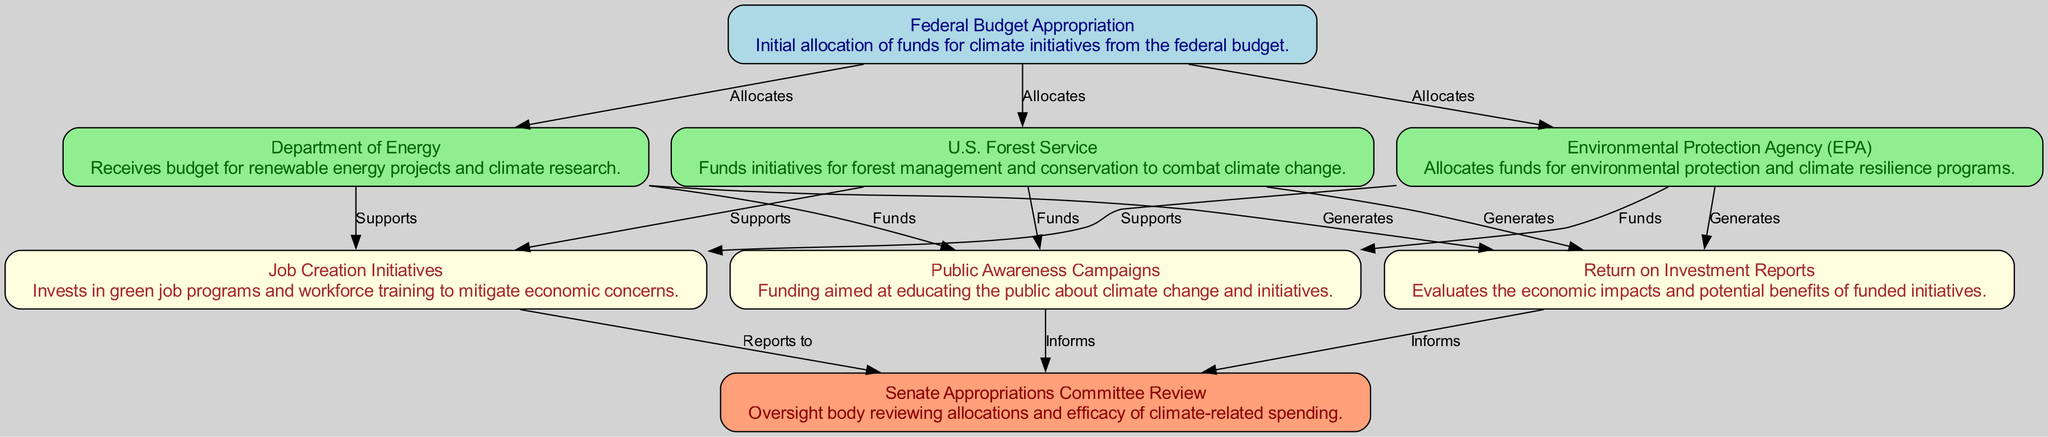What is the initial allocation of funds called? The first node in the diagram represents the starting point of the funding process, labeled "Federal Budget Appropriation." This is the term that designates the initial allocation of funds for climate initiatives.
Answer: Federal Budget Appropriation How many entities receive allocations from the federal budget? By examining the connections stemming from the "Federal Budget Appropriation" node, we see there are three entities listed: Department of Energy, Environmental Protection Agency, and U.S. Forest Service. This indicates a total of three recipients of budget allocations.
Answer: 3 Which entity is responsible for funding environmental protection programs? In the diagram, the node labeled "Environmental Protection Agency (EPA)" specifically states its function as allocating funds for environmental protection and climate resilience programs, making it the clear answer.
Answer: Environmental Protection Agency (EPA) What support does the Department of Energy provide? The flow from the "Department of Energy" shows an arrow leading to "Job Creation Initiatives," indicating that it supports investments in green job programs and workforce training, which directly mitigate economic concerns.
Answer: Job Creation Initiatives How does the diagram indicate economic impact assessments are performed? Following the paths from the funding entities, they all lead to the "Return on Investment Reports" node, which evaluates the economic impacts and benefits of the funding initiatives, demonstrating that economic assessments are a vital part of the process.
Answer: Return on Investment Reports Which node informs the Senate Appropriations Committee? The diagram illustrates that both "Return on Investment Reports" and "Public Awareness Campaigns" have connections pointing toward the "Senate Appropriations Committee Review," indicating that they inform this oversight body about climate-related spending efficacy.
Answer: Return on Investment Reports and Public Awareness Campaigns What is the primary purpose of the “Public Awareness Campaigns”? The node clearly states that the purpose of the "Public Awareness Campaigns" is to educate the public about climate change and initiatives, focusing on raising awareness and understanding.
Answer: Educating the public How many unique flows are generated from the "Federal Budget Appropriation" node? Analyzing the diagram, we can see that the "Federal Budget Appropriation" node generates three unique flows leading to the Department of Energy, EPA, and U.S. Forest Service, highlighting the distribution of funds.
Answer: 3 Which element directly supports funding for green jobs? The connections show that the "Department of Energy," "Environmental Protection Agency (EPA)," and "U.S. Forest Service" all have links to "Job Creation Initiatives," indicating their collective support for green jobs directly.
Answer: Job Creation Initiatives 